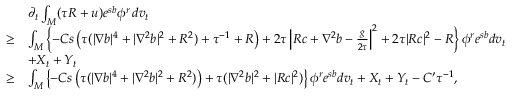<formula> <loc_0><loc_0><loc_500><loc_500>\begin{array} { r l } & { \partial _ { t } \int _ { M } ( \tau R + u ) e ^ { s b } \phi ^ { r } \, d v _ { t } } \\ { \geq } & { \int _ { M } \left \{ - C s \left ( \tau ( | \nabla b | ^ { 4 } + | \nabla ^ { 2 } b | ^ { 2 } + R ^ { 2 } ) + \tau ^ { - 1 } + R \right ) + 2 \tau \left | R c + \nabla ^ { 2 } b - \frac { g } { 2 \tau } \right | ^ { 2 } + 2 \tau | R c | ^ { 2 } - R \right \} \phi ^ { r } e ^ { s b } d v _ { t } } \\ & { + X _ { t } + Y _ { t } } \\ { \geq } & { \int _ { M } \left \{ - C s \left ( \tau ( | \nabla b | ^ { 4 } + | \nabla ^ { 2 } b | ^ { 2 } + R ^ { 2 } ) \right ) + \tau ( | \nabla ^ { 2 } b | ^ { 2 } + | R c | ^ { 2 } ) \right \} \phi ^ { r } e ^ { s b } d v _ { t } + X _ { t } + Y _ { t } - C ^ { \prime } \tau ^ { - 1 } , } \end{array}</formula> 